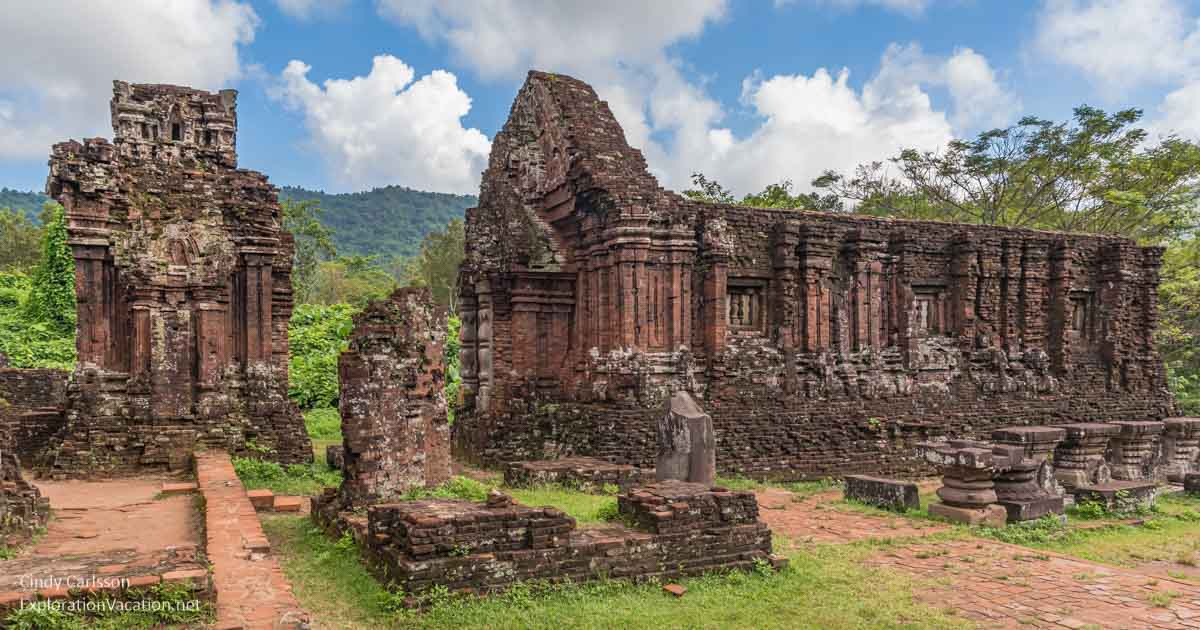Explain the visual content of the image in great detail. This photograph showcases the impressive ancient ruins of the My Son temple complex, a significant historical site in Vietnam. The structures, primarily constructed from weathered red bricks, display various states of preservation and decay, giving a tangible sense of antiquity and history. The scene is bathed in natural light, highlighting the texture and intricate details of the stone carvings and architecture. Small trees and foliage have started to reclaim parts of the ruins, adding a sense of nature’s persistence and the passage of time. The backdrop features lush, green mountains that rise majestically, creating a serene and majestic atmosphere. The sky overhead is a clear blue, accented with soft, puffy white clouds, adding to the overall picturesque and tranquil setting of this historic landmark. 